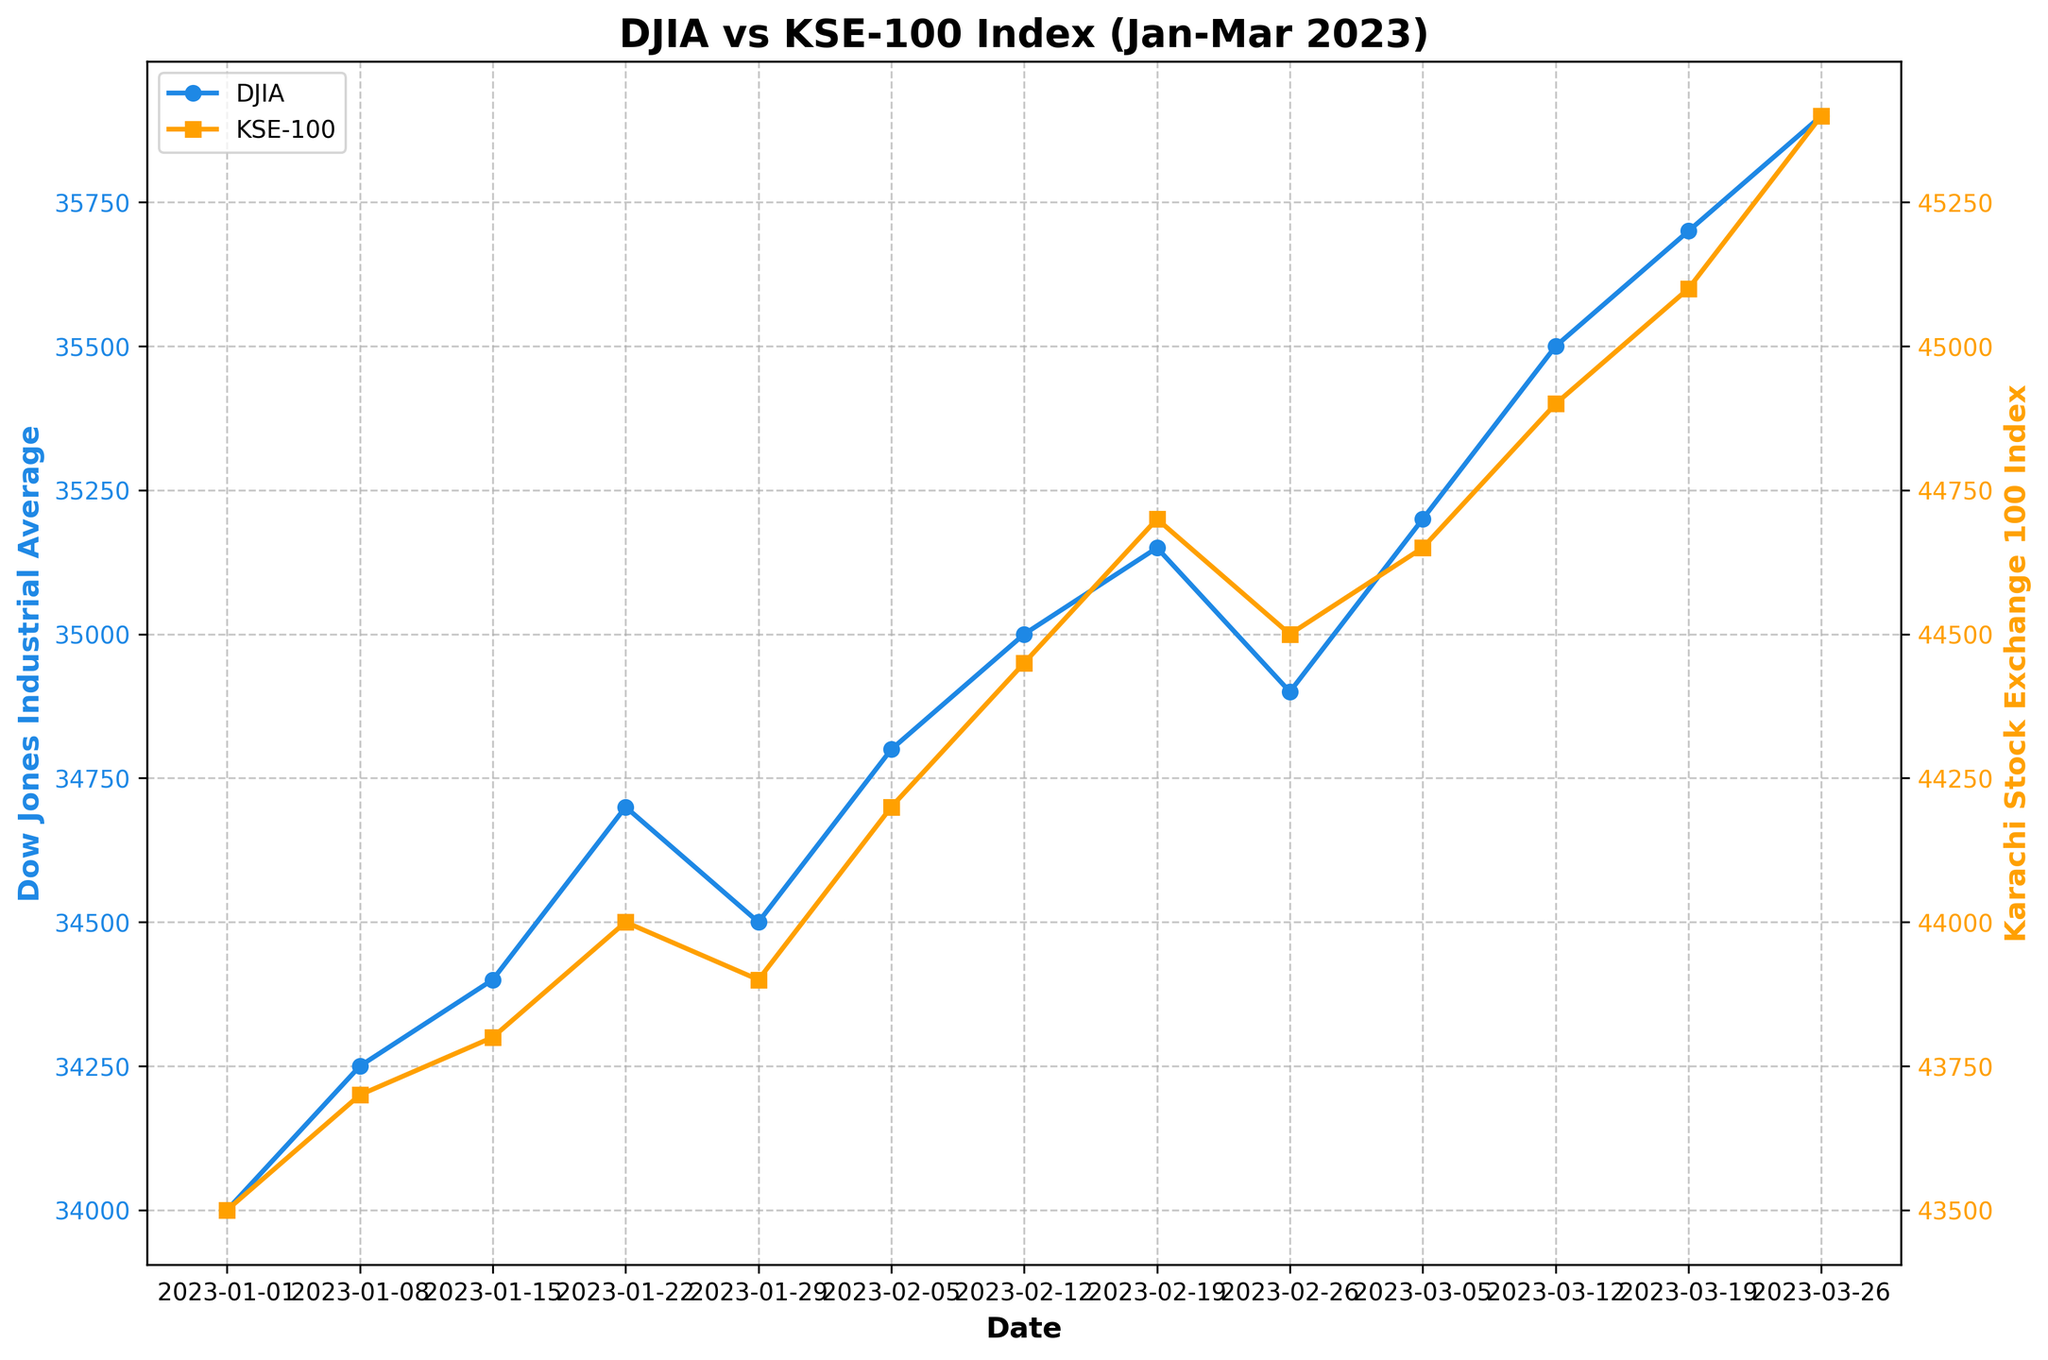What's the title of the figure? The title of the figure is usually located at the top of the plot. In this case, we can read the title displayed clearly.
Answer: DJIA vs KSE-100 Index (Jan-Mar 2023) How many weeks of data are displayed in the figure? The figure displays data points for each week. Counting the data points on the x-axis reveals that there are 13 weeks of data.
Answer: 13 Which index has a label color of blue, and what does the axis represent? The blue color label is associated with the DJIA, as indicated by the color of the line and markers. The y-axis represents the values of the Dow Jones Industrial Average.
Answer: DJIA, Dow Jones Industrial Average Comparing January 1 and March 26, how much did the DJIA increase? On January 1, the DJIA value was 34,000. On March 26, the value was 35,900. The increase is 35,900 - 34,000.
Answer: 1,900 Which index showed a higher increase between the start and end of the period, DJIA or KSE-100? Starting values are DJIA 34,000 and KSE-100 43,500. Ending values are DJIA 35,900 and KSE-100 45,400. Calculate the increases: DJIA 1,900, KSE-100 1,900. Both indices showed the same increase.
Answer: Both showed the same increase How many times did the KSE-100 Index touch or exceed 45,000 during the given period? By looking at the y-axis on the right and tracing the KSE-100 line, we notice that it touches or exceeds 45,000 twice: on March 19 and March 26.
Answer: 2 On which dates did the DJIA surpass 35,000 during this period? By tracing the blue line, we observe that the DJIA surpasses 35,000 on March 12, March 19, March 26.
Answer: March 12, March 19, March 26 What's the average number of visitors to Mohenjo-daro over the period? Sum the values: 1500 + 1600 + 1580 + 1620 + 1650 + 1700 + 1680 + 1750 + 1800 + 1850 + 1900 + 1950 + 2000 = 22780. There are 13 weeks, so the average is 22780/13.
Answer: 1,752 